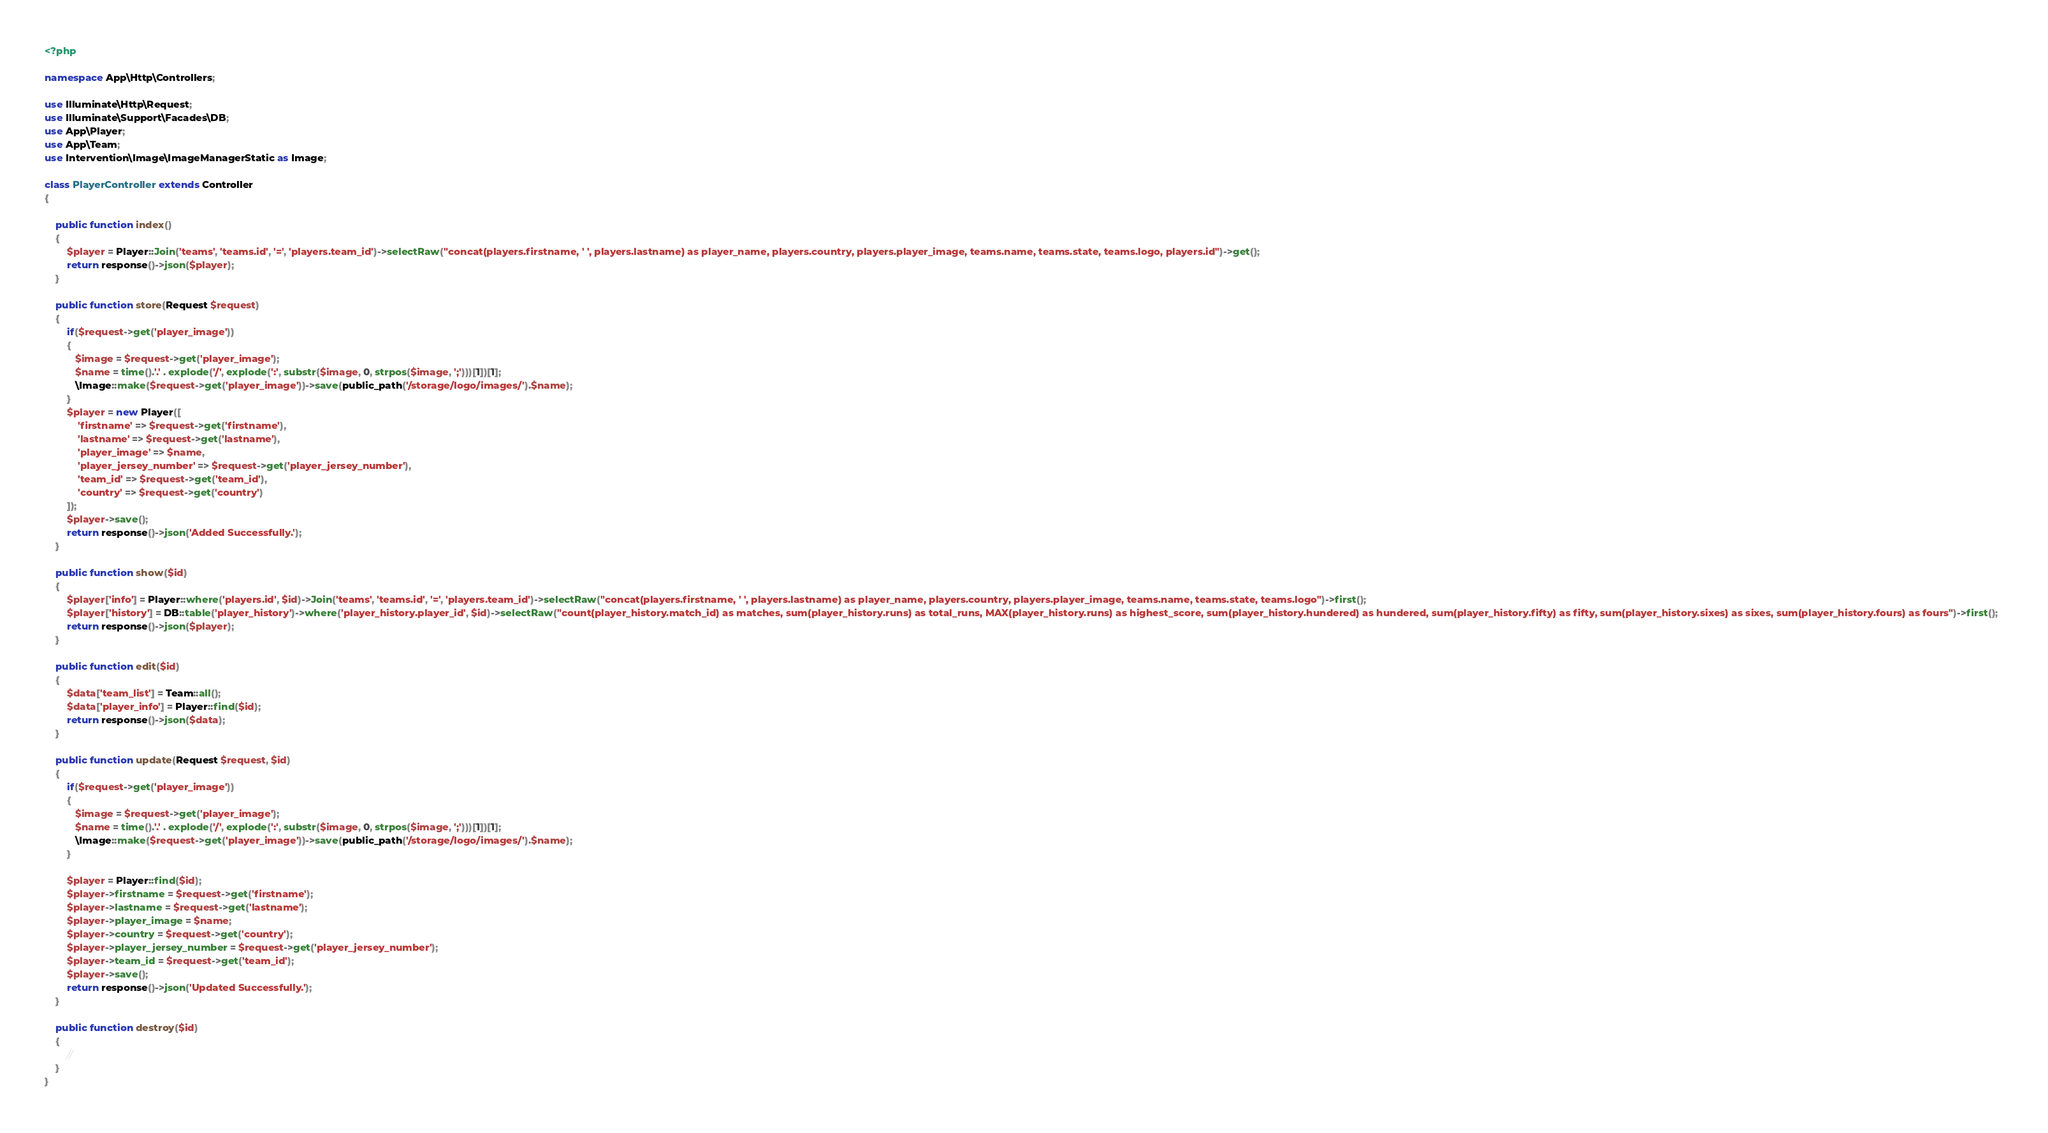Convert code to text. <code><loc_0><loc_0><loc_500><loc_500><_PHP_><?php

namespace App\Http\Controllers;

use Illuminate\Http\Request;
use Illuminate\Support\Facades\DB;
use App\Player;
use App\Team;
use Intervention\Image\ImageManagerStatic as Image;

class PlayerController extends Controller
{

    public function index()
    {
        $player = Player::Join('teams', 'teams.id', '=', 'players.team_id')->selectRaw("concat(players.firstname, ' ', players.lastname) as player_name, players.country, players.player_image, teams.name, teams.state, teams.logo, players.id")->get();
        return response()->json($player);
    }

    public function store(Request $request)
    {
        if($request->get('player_image'))
        {
           $image = $request->get('player_image');
           $name = time().'.' . explode('/', explode(':', substr($image, 0, strpos($image, ';')))[1])[1];
           \Image::make($request->get('player_image'))->save(public_path('/storage/logo/images/').$name);
        }
        $player = new Player([
            'firstname' => $request->get('firstname'),
            'lastname' => $request->get('lastname'),
            'player_image' => $name,
            'player_jersey_number' => $request->get('player_jersey_number'),
            'team_id' => $request->get('team_id'),
            'country' => $request->get('country')
        ]);
        $player->save();
        return response()->json('Added Successfully.');
    }

    public function show($id)
    {
        $player['info'] = Player::where('players.id', $id)->Join('teams', 'teams.id', '=', 'players.team_id')->selectRaw("concat(players.firstname, ' ', players.lastname) as player_name, players.country, players.player_image, teams.name, teams.state, teams.logo")->first();
        $player['history'] = DB::table('player_history')->where('player_history.player_id', $id)->selectRaw("count(player_history.match_id) as matches, sum(player_history.runs) as total_runs, MAX(player_history.runs) as highest_score, sum(player_history.hundered) as hundered, sum(player_history.fifty) as fifty, sum(player_history.sixes) as sixes, sum(player_history.fours) as fours")->first();  
        return response()->json($player);
    }

    public function edit($id)
    {
        $data['team_list'] = Team::all();
        $data['player_info'] = Player::find($id);
        return response()->json($data);
    }
    
    public function update(Request $request, $id)
    {
        if($request->get('player_image'))
        {
           $image = $request->get('player_image');
           $name = time().'.' . explode('/', explode(':', substr($image, 0, strpos($image, ';')))[1])[1];
           \Image::make($request->get('player_image'))->save(public_path('/storage/logo/images/').$name);
        }

        $player = Player::find($id);
        $player->firstname = $request->get('firstname');
        $player->lastname = $request->get('lastname');
        $player->player_image = $name;
        $player->country = $request->get('country');
        $player->player_jersey_number = $request->get('player_jersey_number');
        $player->team_id = $request->get('team_id');
        $player->save();
        return response()->json('Updated Successfully.');
    }

    public function destroy($id)
    {
        //
    }
}
</code> 